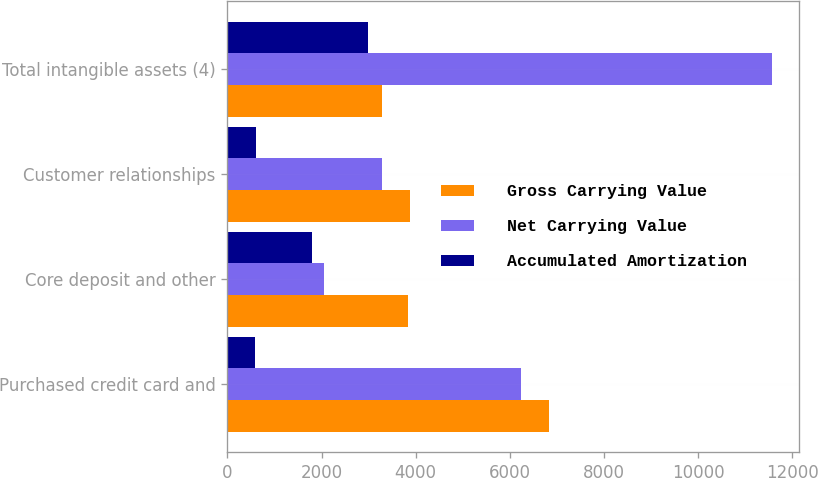<chart> <loc_0><loc_0><loc_500><loc_500><stacked_bar_chart><ecel><fcel>Purchased credit card and<fcel>Core deposit and other<fcel>Customer relationships<fcel>Total intangible assets (4)<nl><fcel>Gross Carrying Value<fcel>6830<fcel>3836<fcel>3887<fcel>3275<nl><fcel>Net Carrying Value<fcel>6243<fcel>2046<fcel>3275<fcel>11564<nl><fcel>Accumulated Amortization<fcel>587<fcel>1790<fcel>612<fcel>2989<nl></chart> 